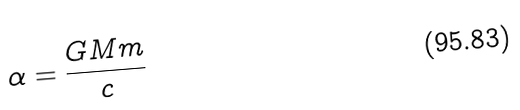Convert formula to latex. <formula><loc_0><loc_0><loc_500><loc_500>\alpha = \frac { G M m } { c }</formula> 